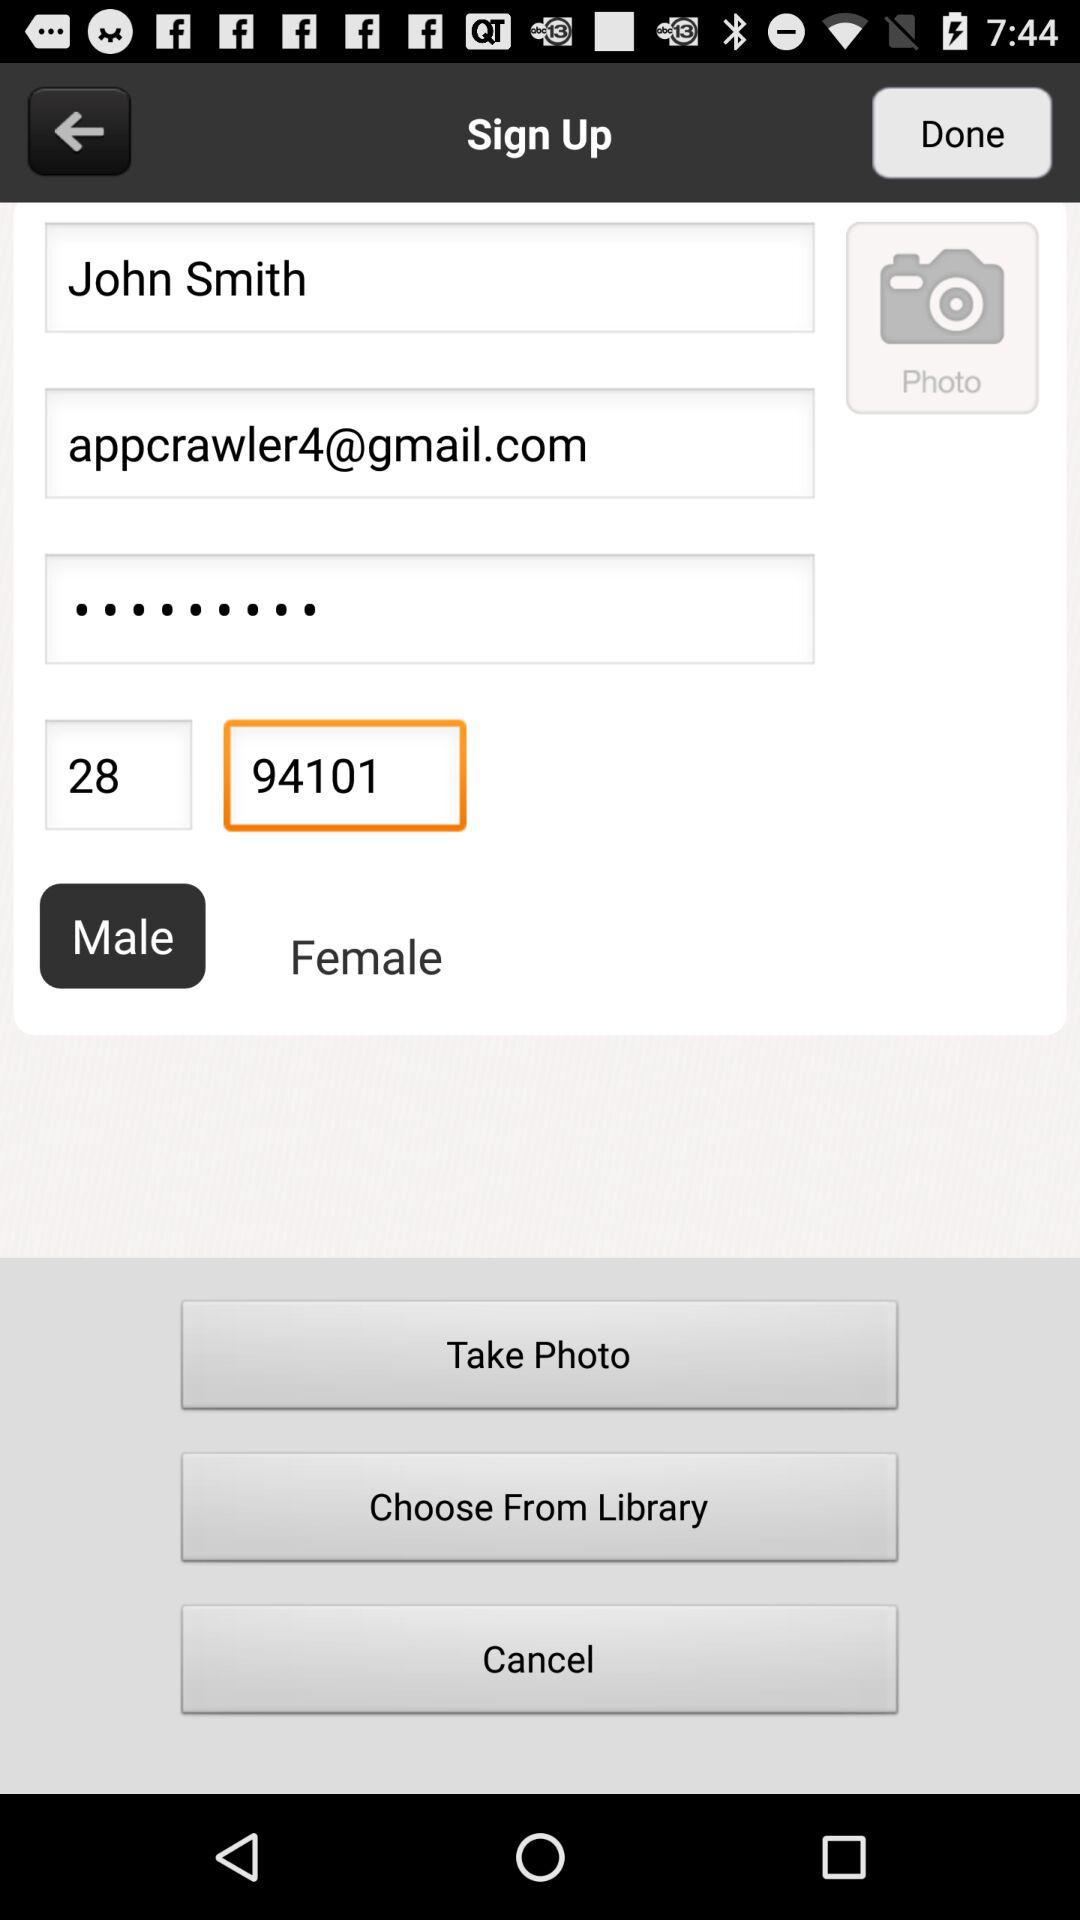What is the email address? The email address is appcrawler4@gmail.com. 